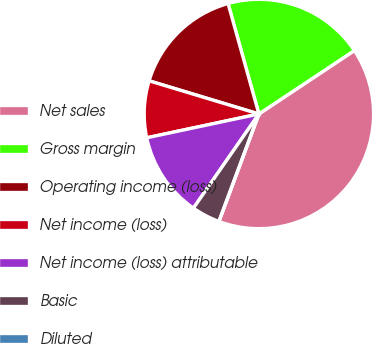<chart> <loc_0><loc_0><loc_500><loc_500><pie_chart><fcel>Net sales<fcel>Gross margin<fcel>Operating income (loss)<fcel>Net income (loss)<fcel>Net income (loss) attributable<fcel>Basic<fcel>Diluted<nl><fcel>40.0%<fcel>20.0%<fcel>16.0%<fcel>8.0%<fcel>12.0%<fcel>4.0%<fcel>0.0%<nl></chart> 